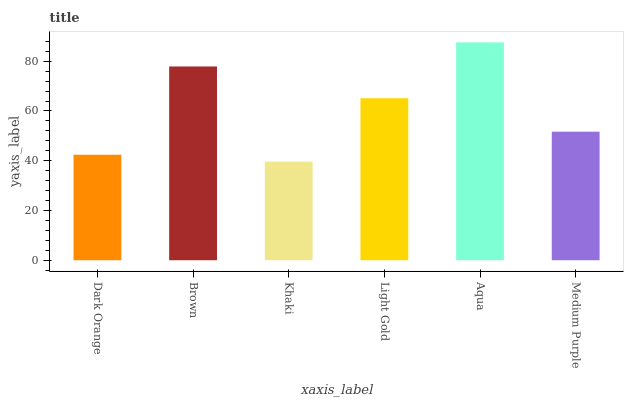Is Brown the minimum?
Answer yes or no. No. Is Brown the maximum?
Answer yes or no. No. Is Brown greater than Dark Orange?
Answer yes or no. Yes. Is Dark Orange less than Brown?
Answer yes or no. Yes. Is Dark Orange greater than Brown?
Answer yes or no. No. Is Brown less than Dark Orange?
Answer yes or no. No. Is Light Gold the high median?
Answer yes or no. Yes. Is Medium Purple the low median?
Answer yes or no. Yes. Is Brown the high median?
Answer yes or no. No. Is Brown the low median?
Answer yes or no. No. 